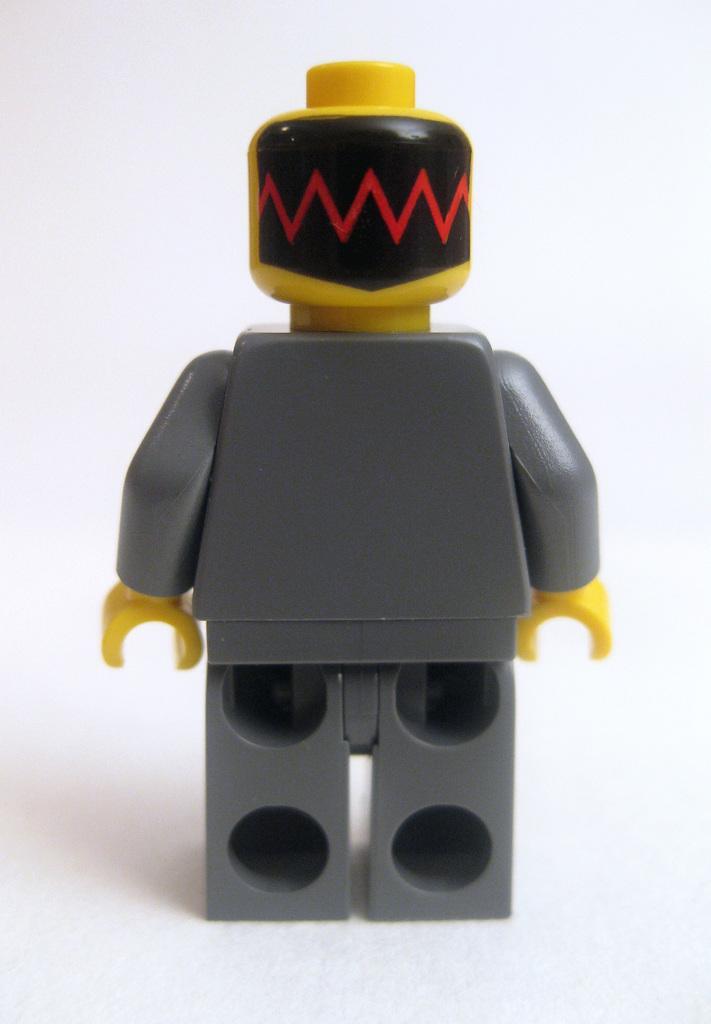Describe this image in one or two sentences. We can see you on the white platform. In the background it is white. 